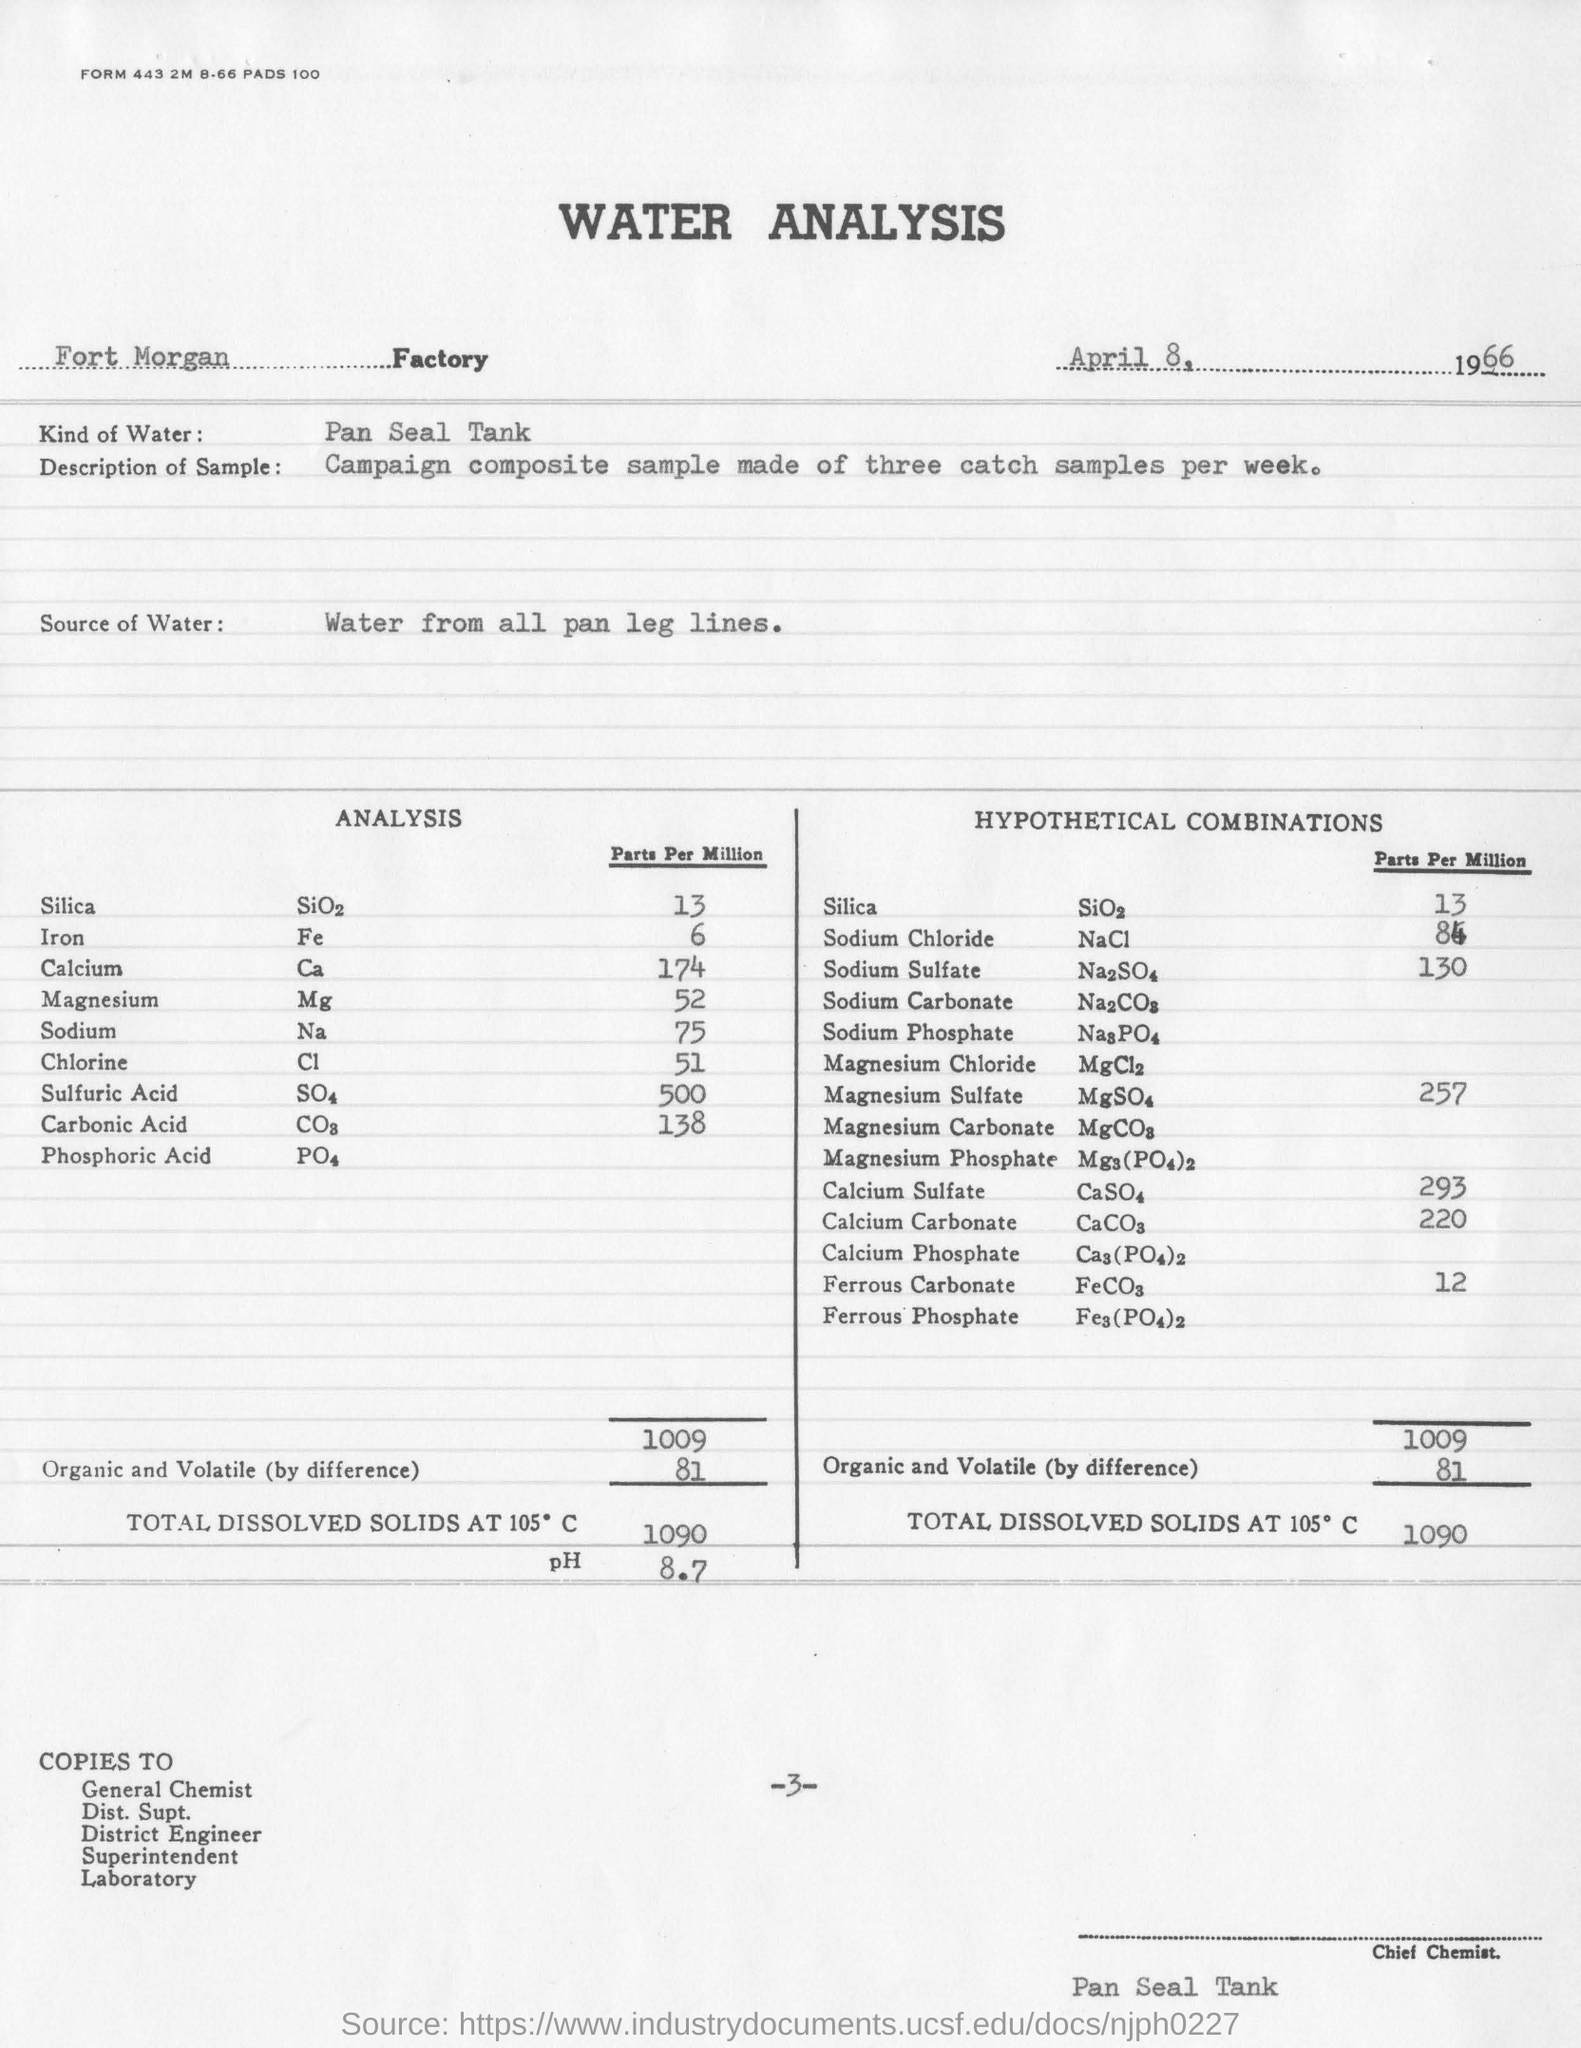Indicate a few pertinent items in this graphic. In the hypothetical combinations, there was a total of 13 parts per million of silica. The date of the analysis is April 8, 1966. A total of three samples were taken. 